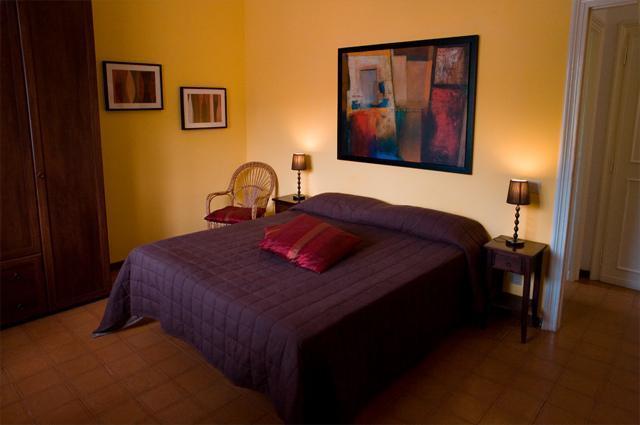How many lamps are in the room?
Give a very brief answer. 2. How many pictures are hung on the wall in this scene?
Give a very brief answer. 3. How many chairs are visible?
Give a very brief answer. 1. 